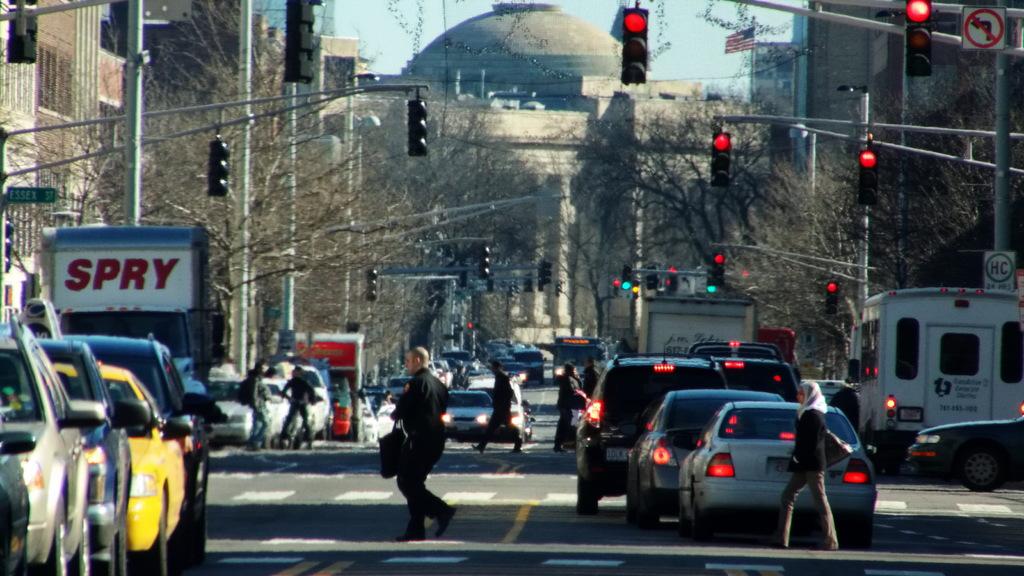What company does the big truck on the left belong to?
Provide a short and direct response. Spry. What letters are on the sign on the right pole?
Ensure brevity in your answer.  Hc. 